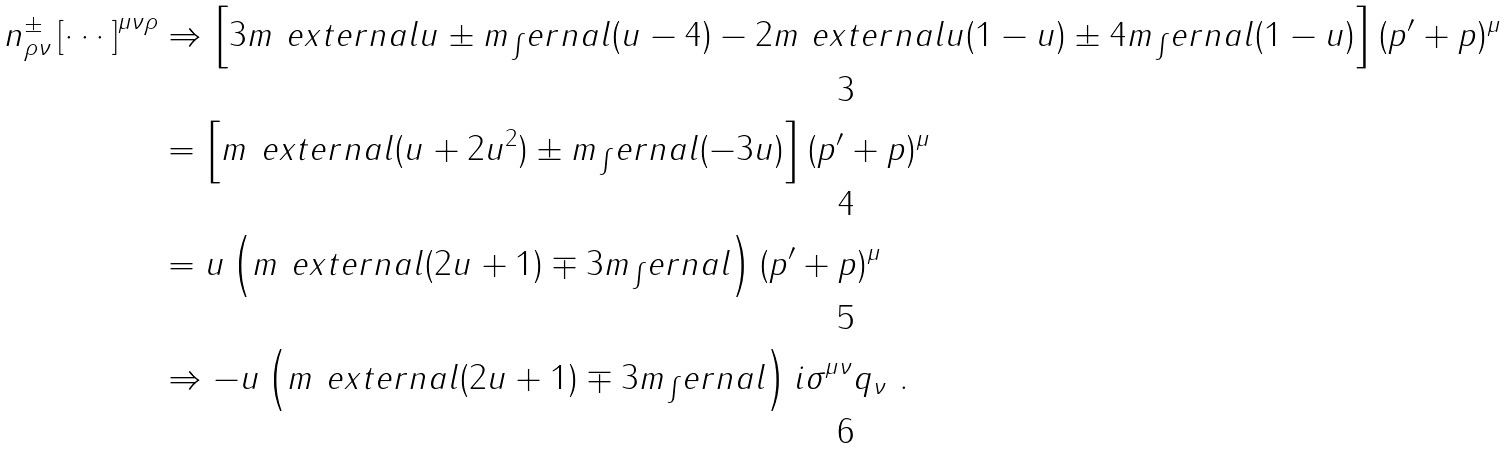Convert formula to latex. <formula><loc_0><loc_0><loc_500><loc_500>n _ { \rho \nu } ^ { \pm } \left [ \cdots \right ] ^ { \mu \nu \rho } & \Rightarrow \left [ 3 m _ { \ } e x t e r n a l u \pm m _ { \int } e r n a l ( u - 4 ) - 2 m _ { \ } e x t e r n a l u ( 1 - u ) \pm 4 m _ { \int } e r n a l ( 1 - u ) \right ] ( p ^ { \prime } + p ) ^ { \mu } \\ & = \left [ m _ { \ } e x t e r n a l ( u + 2 u ^ { 2 } ) \pm m _ { \int } e r n a l ( - 3 u ) \right ] ( p ^ { \prime } + p ) ^ { \mu } \\ & = u \left ( m _ { \ } e x t e r n a l ( 2 u + 1 ) \mp 3 m _ { \int } e r n a l \right ) ( p ^ { \prime } + p ) ^ { \mu } \\ & \Rightarrow - u \left ( m _ { \ } e x t e r n a l ( 2 u + 1 ) \mp 3 m _ { \int } e r n a l \right ) i \sigma ^ { \mu \nu } q _ { \nu } \ .</formula> 